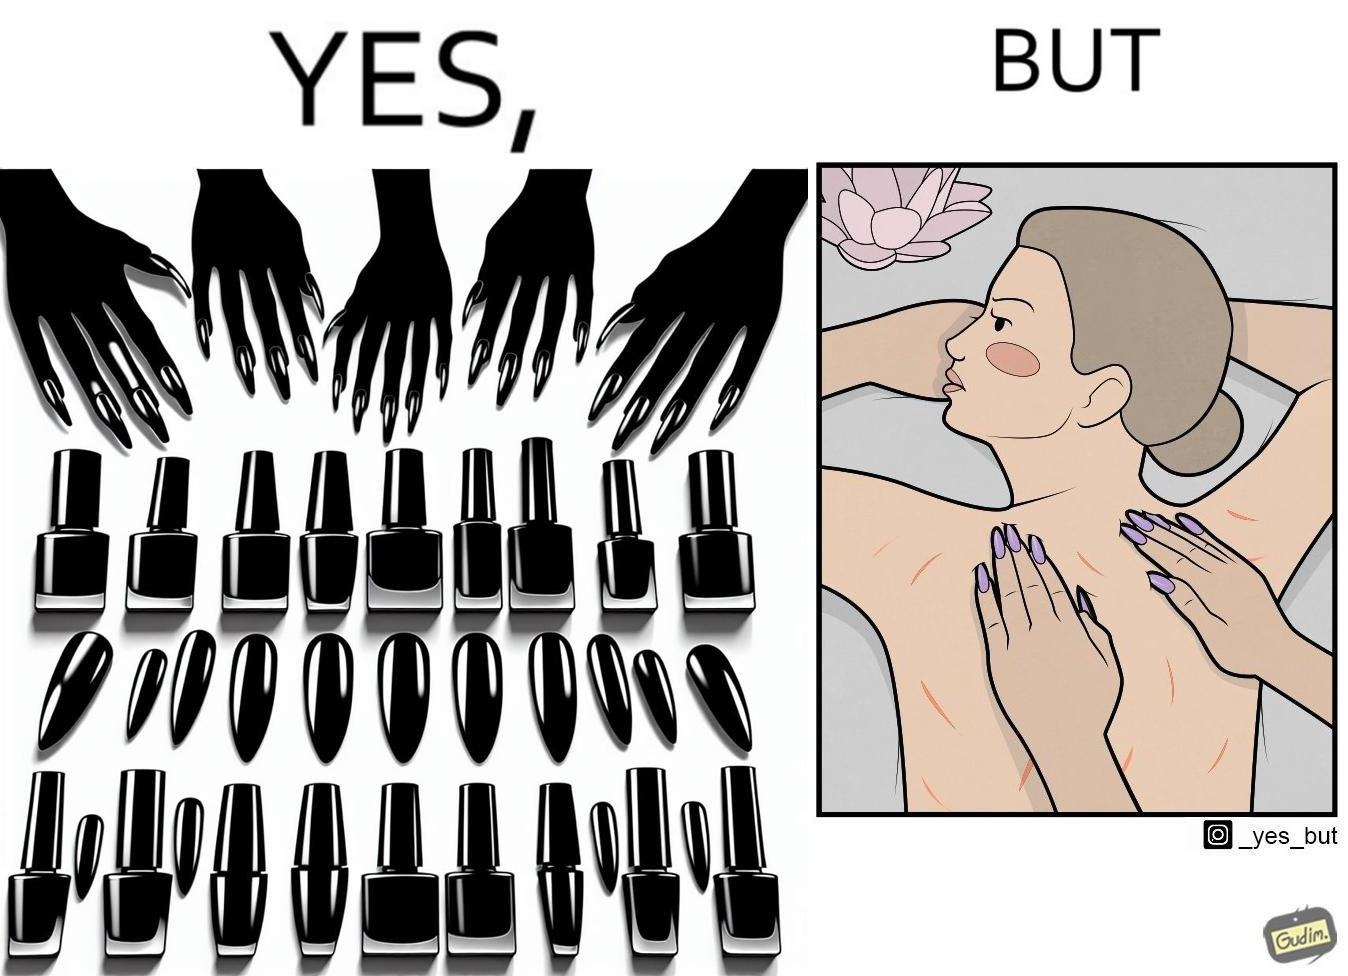Is there satirical content in this image? Yes, this image is satirical. 